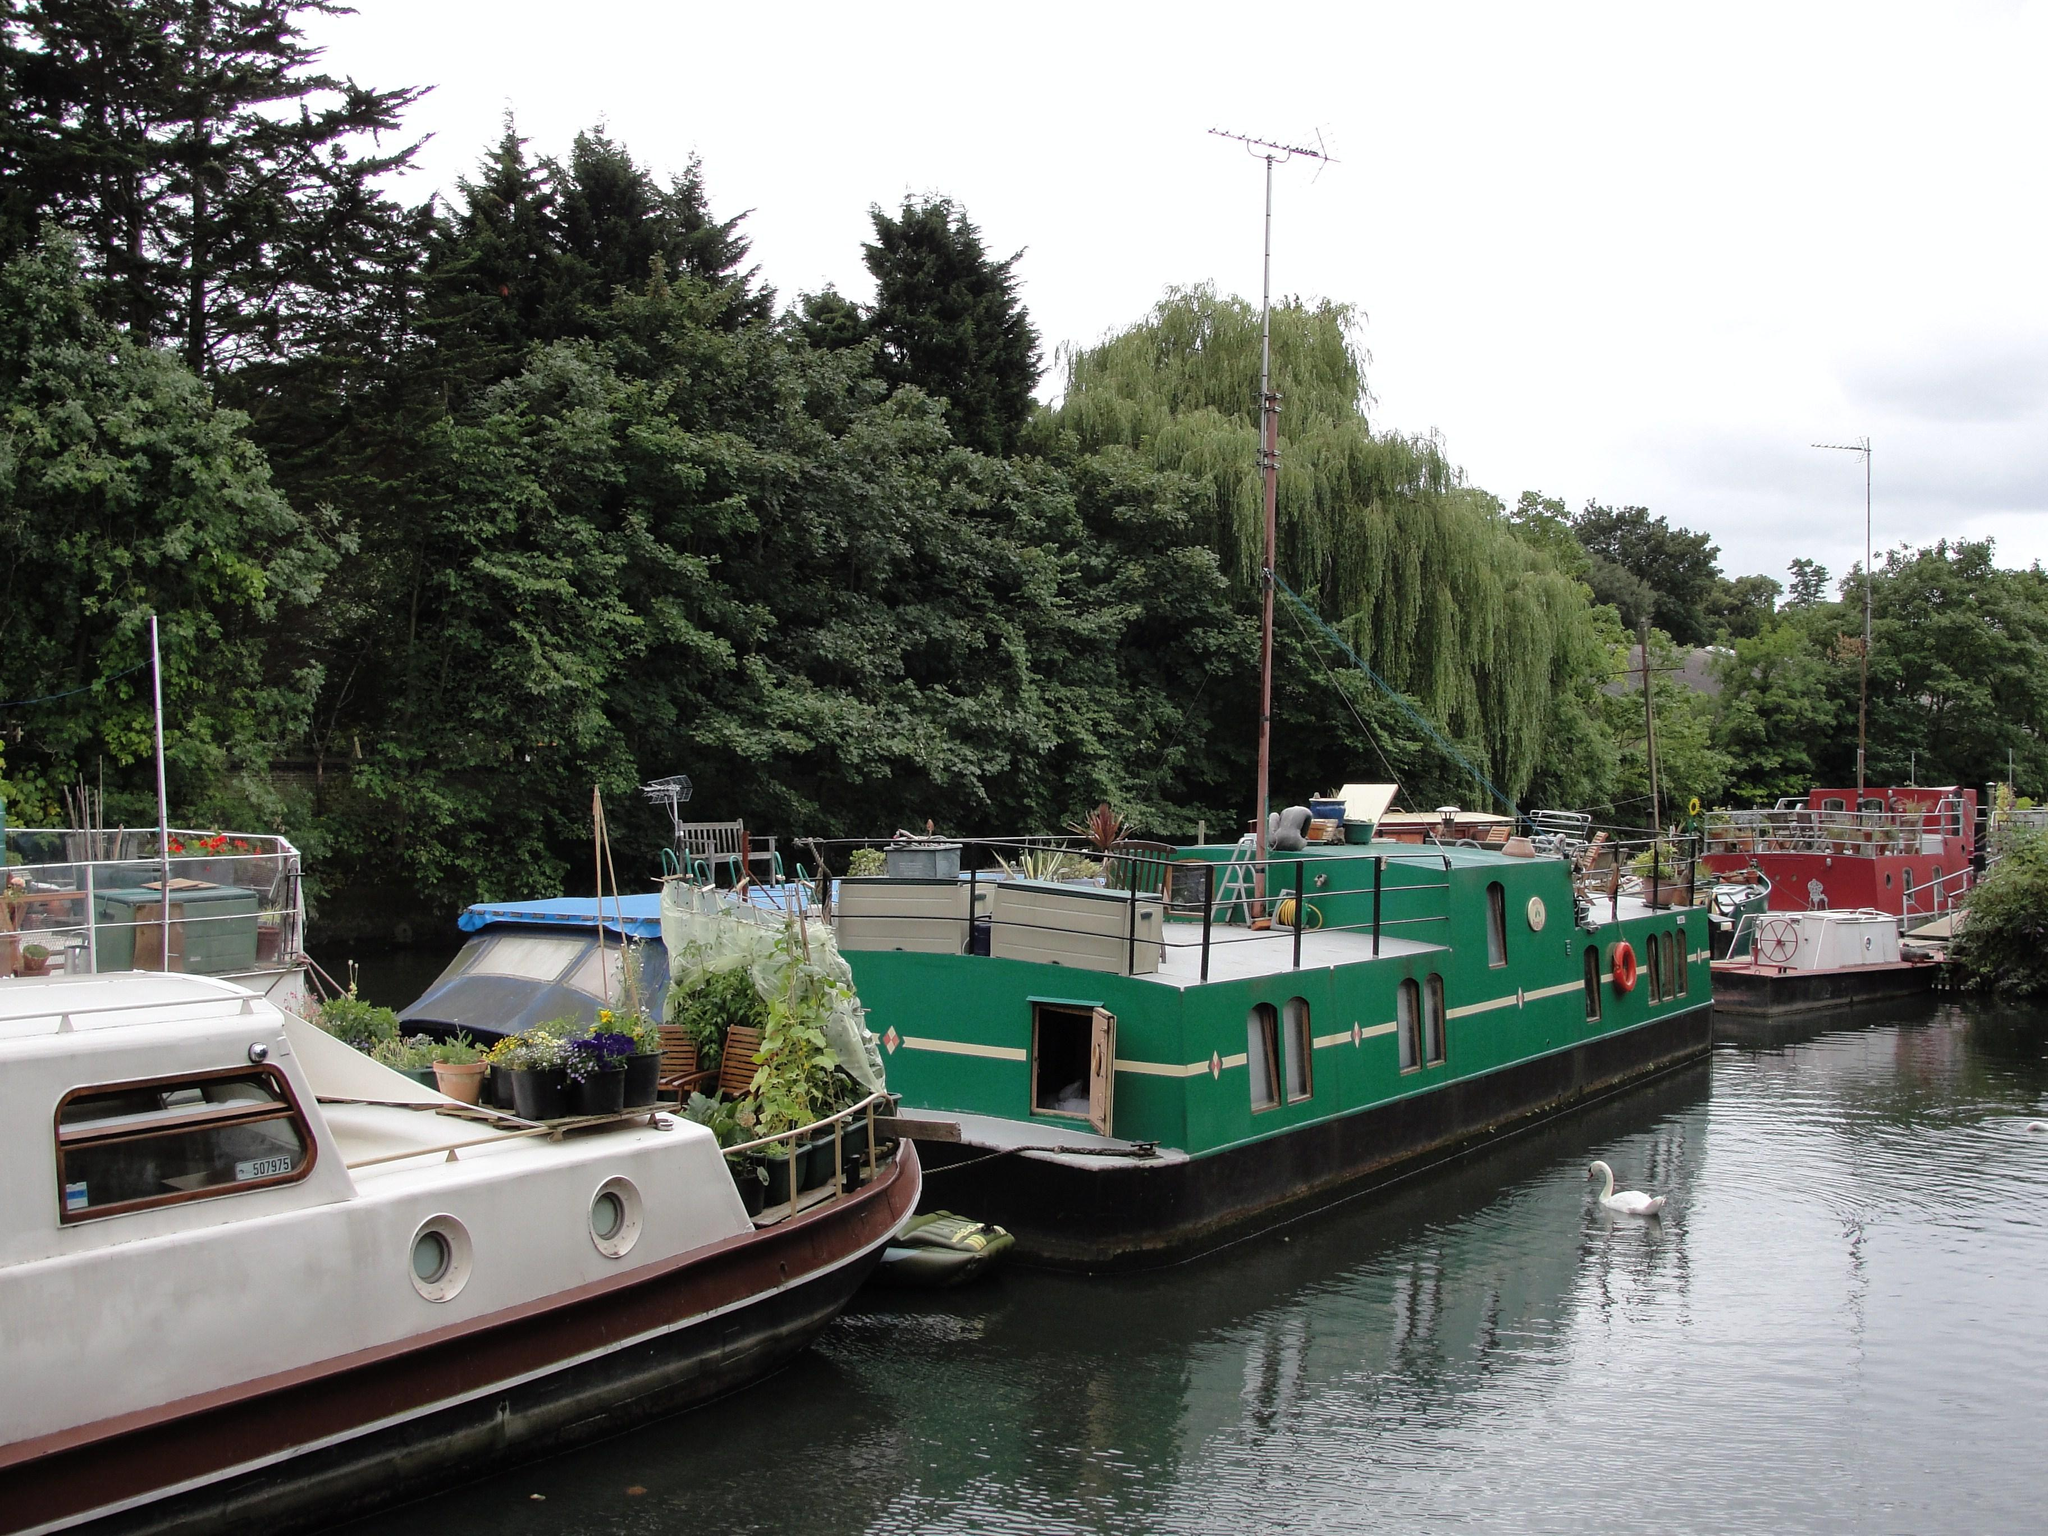What body of water is present in the image? There is a lake in the image. What is in the lake besides water? There are boats and a swan in the lake. What can be seen in the background of the image? There are trees, poles, and the sky visible in the background of the image. Can you see a robin perched on one of the poles in the image? There is no robin present in the image; only the lake, boats, swan, trees, poles, and sky are visible. 